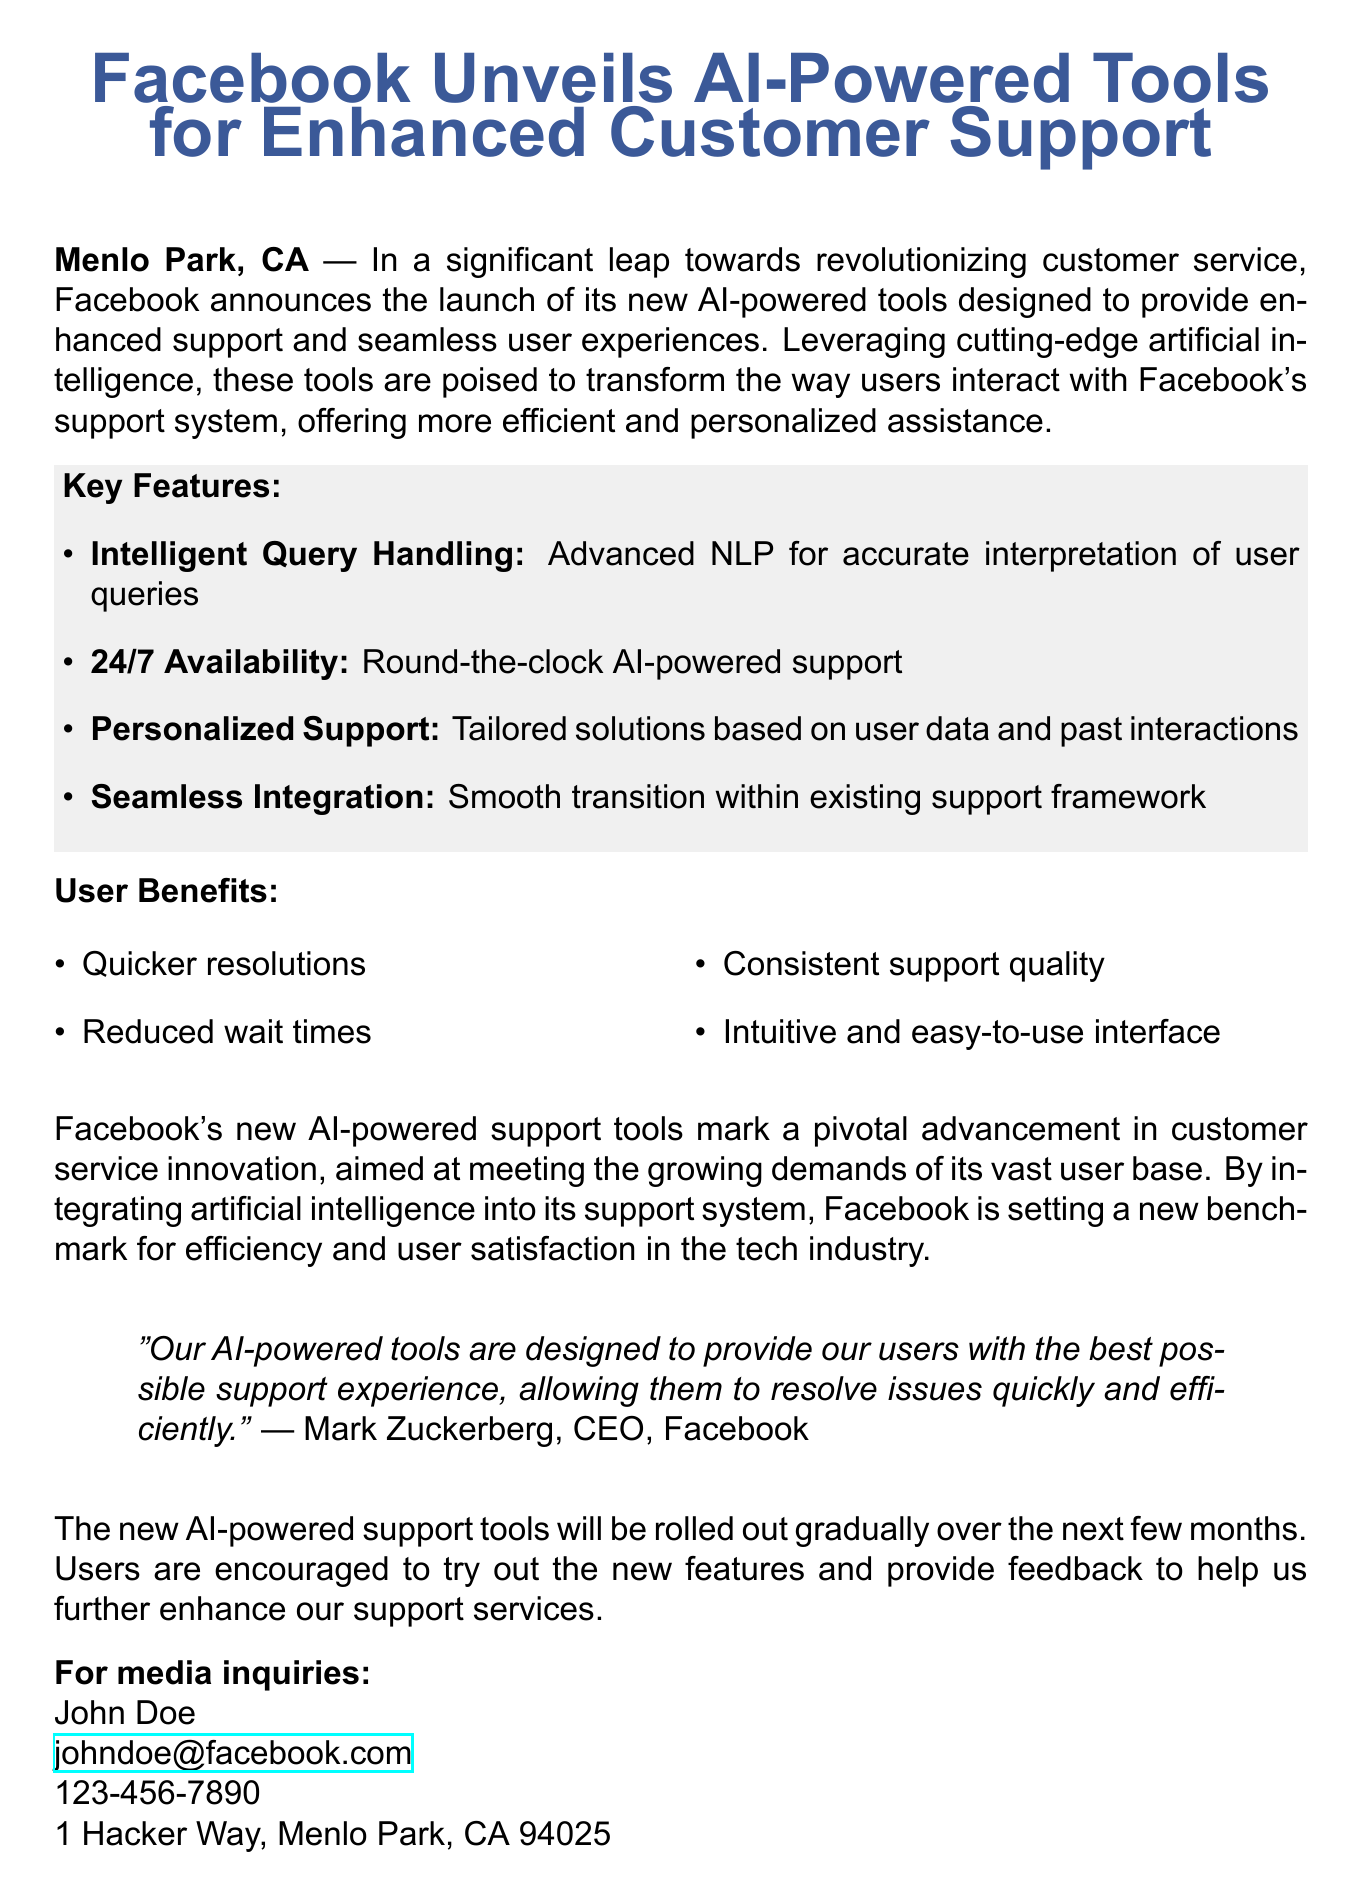What are the key features of the new AI tools? The key features are listed in a bulleted itemization that includes Intelligent Query Handling, 24/7 Availability, Personalized Support, and Seamless Integration.
Answer: Intelligent Query Handling, 24/7 Availability, Personalized Support, Seamless Integration Who is the CEO of Facebook? The document quotes the CEO of Facebook, whose name is provided.
Answer: Mark Zuckerberg What type of artificial intelligence is used in the new tools? The document describes the AI technology used for support as leveraging advanced NLP (Natural Language Processing).
Answer: NLP How many benefits are listed for users? The number of user benefits is indicated by counting the items in the benefit section of the document.
Answer: Four When will the AI-powered support tools be rolled out? The document states that the tools will be rolled out gradually over the next few months.
Answer: Over the next few months What is the primary aim of the new AI tools? The document clearly states the aim of the AI tools in enhancing customer service.
Answer: Enhanced support and seamless user experiences Who can be contacted for media inquiries? The document provides the name of the person responsible for media inquiries.
Answer: John Doe 